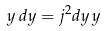<formula> <loc_0><loc_0><loc_500><loc_500>y \, d y = j ^ { 2 } d y \, y</formula> 